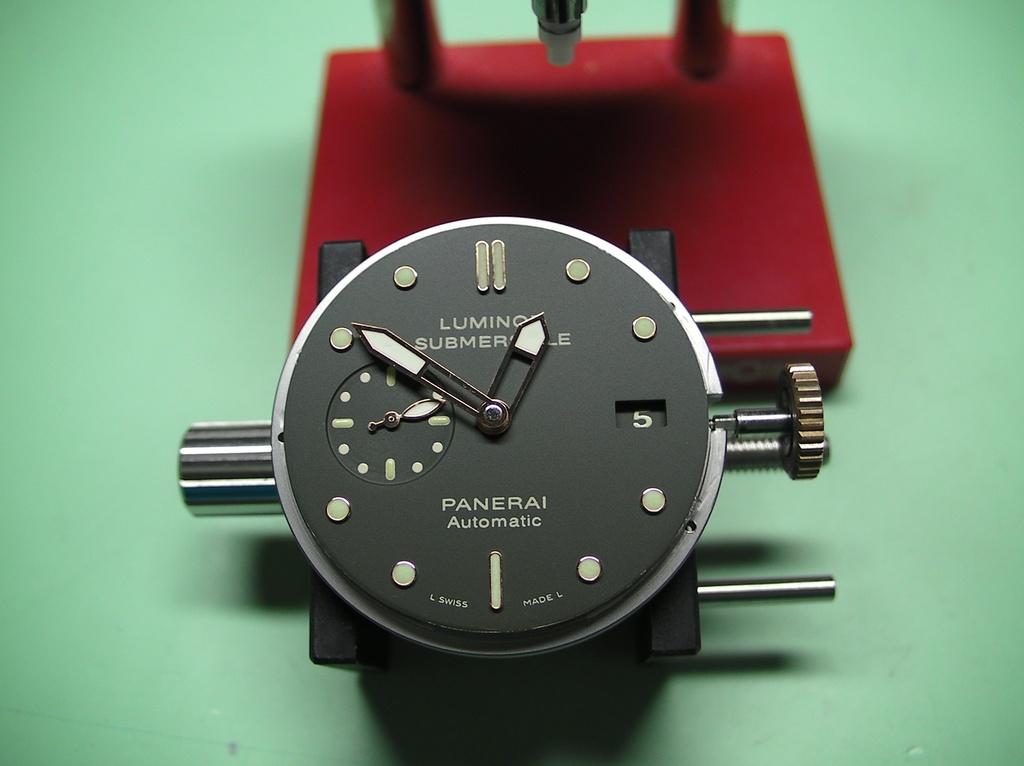What is the brand of this watch?
Offer a terse response. Panerai. What time does the watch say?
Give a very brief answer. 12:51. 